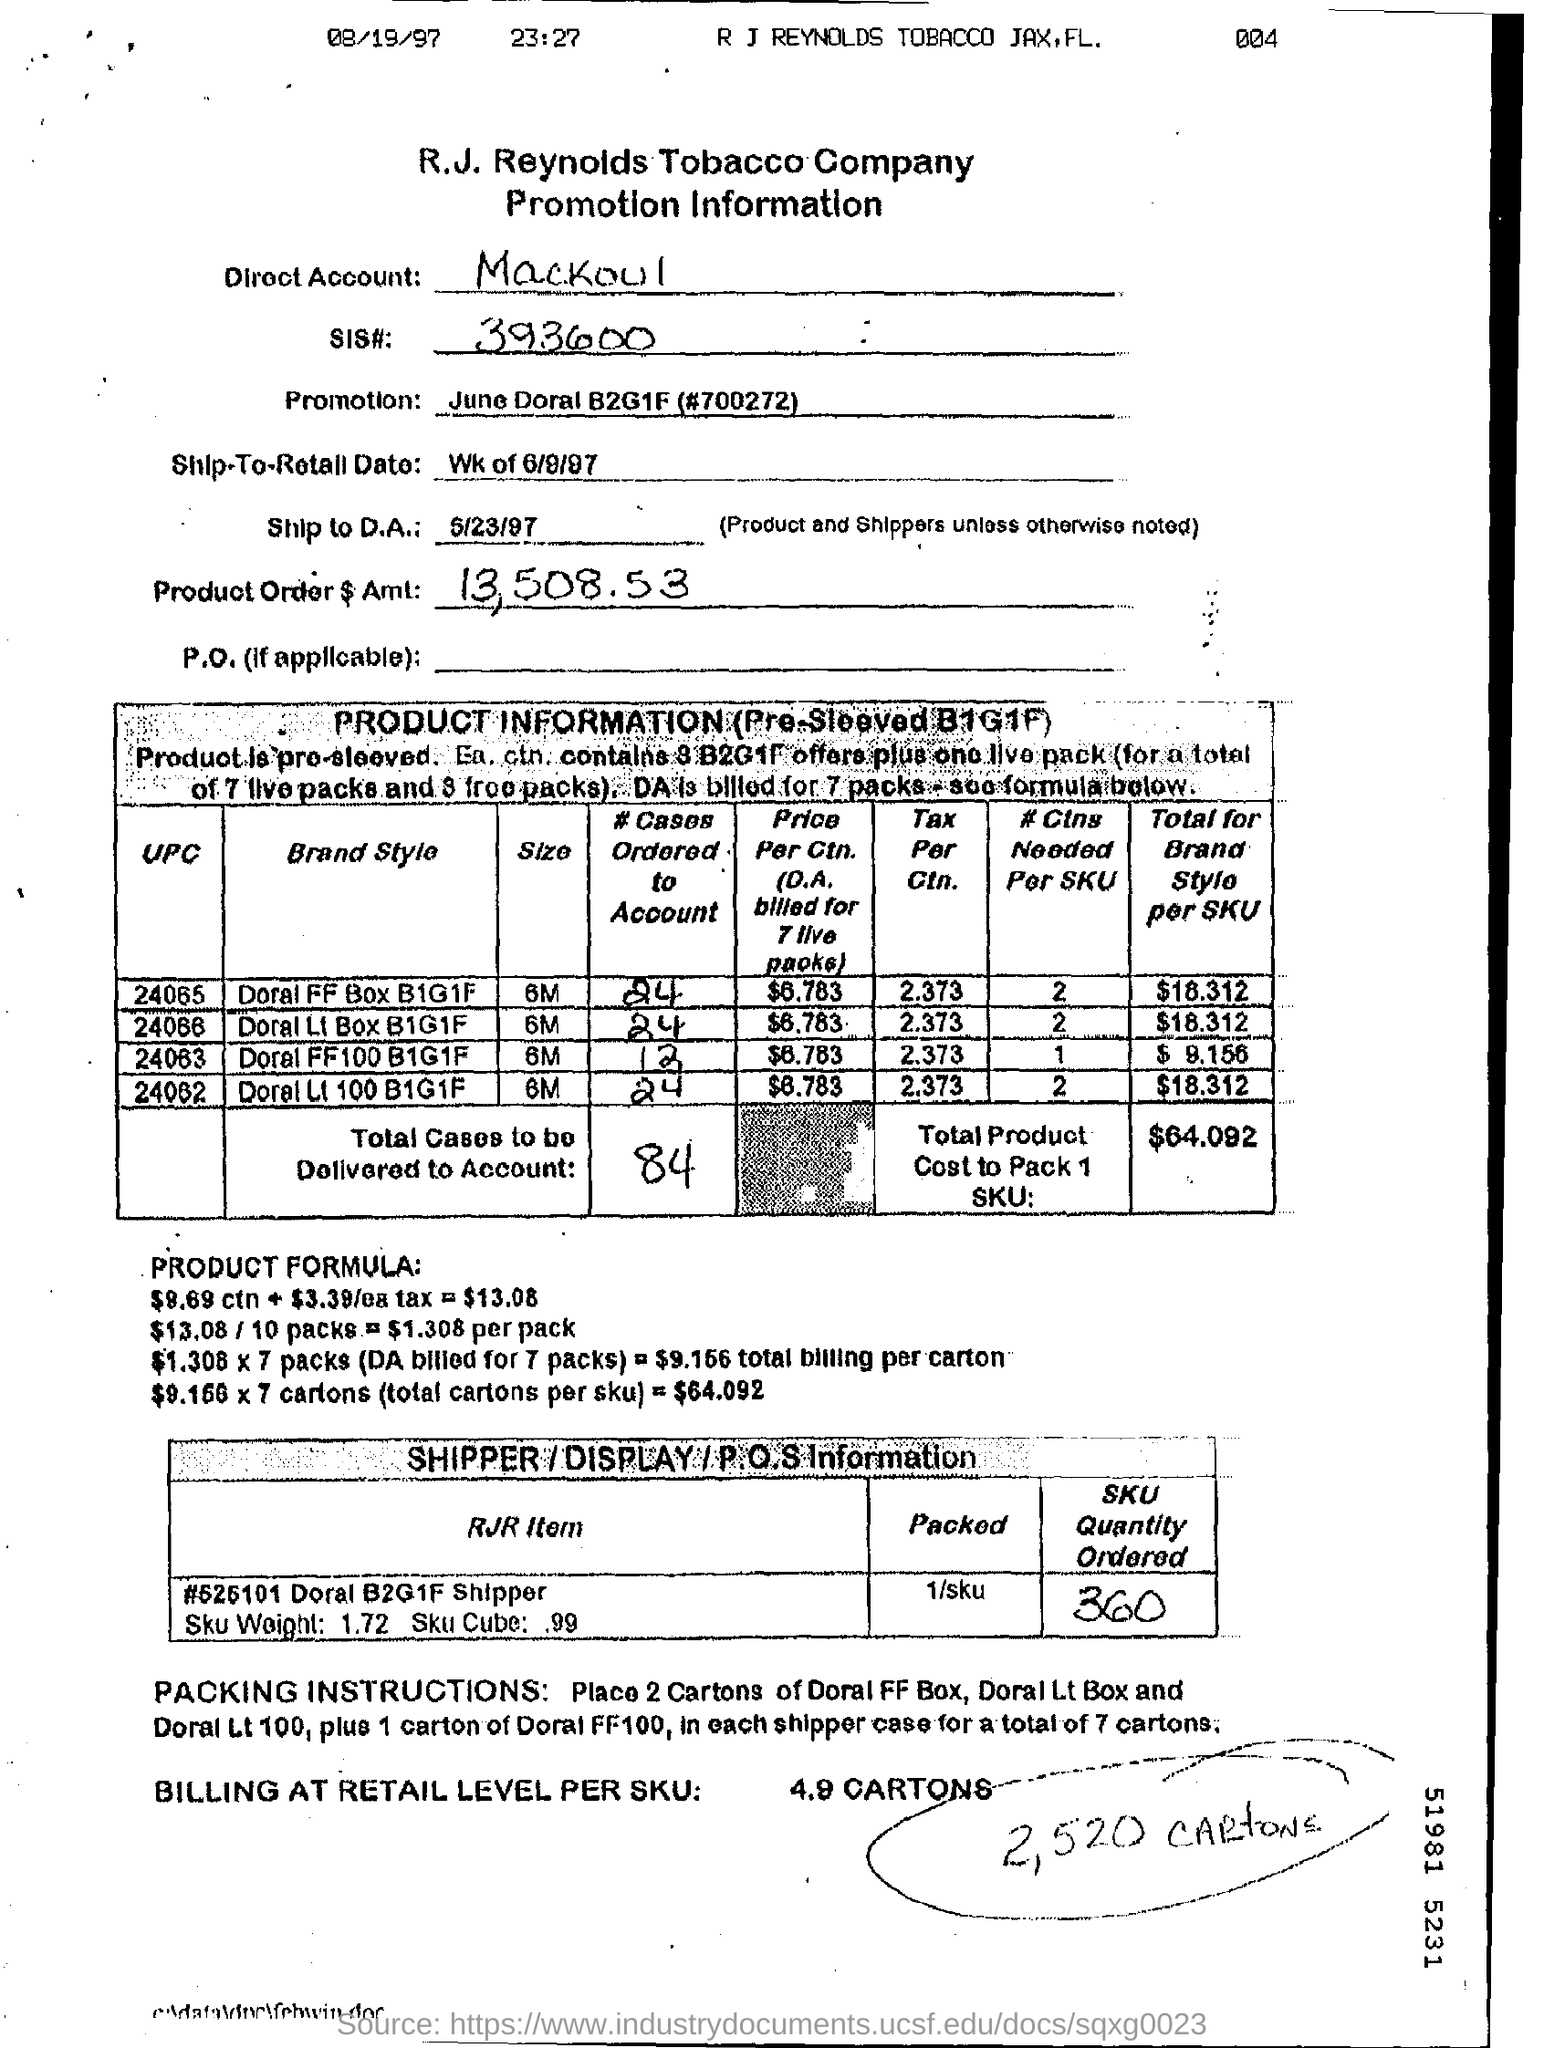What is the name of the company ?
Offer a terse response. R.J Reynolds Tobacco company. What is mentioned in the direct account ?
Give a very brief answer. Mackoul. What is the product order$ amt ?
Your response must be concise. 13,508.53. What is the date mentioned ?
Offer a terse response. 08/19/97. What is the time mentioned ?
Provide a short and direct response. 23:27. How much sku quantity is ordered?
Make the answer very short. 360. What is the sku weight ?
Give a very brief answer. 1.72. How much total cases to be delivered to account
Make the answer very short. 84. 